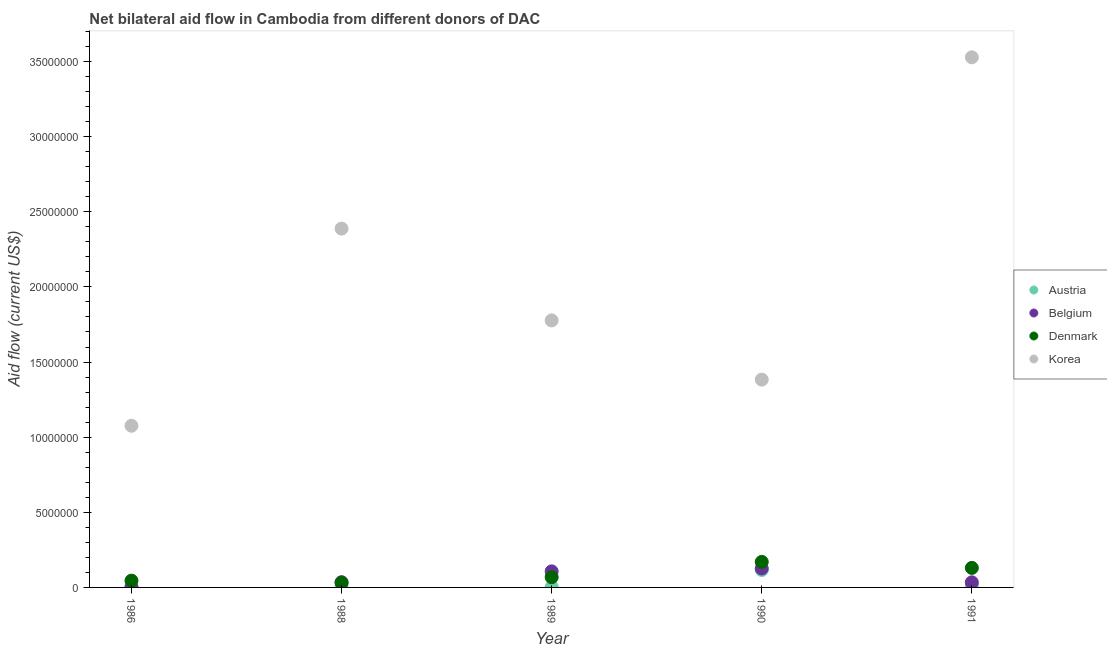How many different coloured dotlines are there?
Your answer should be compact. 4. Is the number of dotlines equal to the number of legend labels?
Ensure brevity in your answer.  Yes. What is the amount of aid given by austria in 1990?
Provide a succinct answer. 1.16e+06. Across all years, what is the maximum amount of aid given by korea?
Your answer should be compact. 3.53e+07. Across all years, what is the minimum amount of aid given by austria?
Your response must be concise. 3.00e+04. What is the total amount of aid given by denmark in the graph?
Your answer should be very brief. 4.44e+06. What is the difference between the amount of aid given by denmark in 1989 and that in 1990?
Offer a terse response. -1.02e+06. What is the difference between the amount of aid given by korea in 1988 and the amount of aid given by austria in 1986?
Provide a succinct answer. 2.38e+07. What is the average amount of aid given by denmark per year?
Provide a succinct answer. 8.88e+05. In the year 1988, what is the difference between the amount of aid given by austria and amount of aid given by belgium?
Your answer should be compact. -3.10e+05. What is the ratio of the amount of aid given by austria in 1988 to that in 1989?
Provide a succinct answer. 1.33. Is the amount of aid given by austria in 1986 less than that in 1991?
Offer a terse response. Yes. What is the difference between the highest and the lowest amount of aid given by korea?
Provide a short and direct response. 2.45e+07. Is it the case that in every year, the sum of the amount of aid given by denmark and amount of aid given by austria is greater than the sum of amount of aid given by belgium and amount of aid given by korea?
Your answer should be very brief. Yes. Is it the case that in every year, the sum of the amount of aid given by austria and amount of aid given by belgium is greater than the amount of aid given by denmark?
Ensure brevity in your answer.  No. Does the amount of aid given by austria monotonically increase over the years?
Keep it short and to the point. No. Is the amount of aid given by korea strictly less than the amount of aid given by austria over the years?
Provide a short and direct response. No. How many dotlines are there?
Give a very brief answer. 4. How many years are there in the graph?
Keep it short and to the point. 5. What is the difference between two consecutive major ticks on the Y-axis?
Your response must be concise. 5.00e+06. Does the graph contain any zero values?
Your answer should be very brief. No. Does the graph contain grids?
Offer a terse response. No. Where does the legend appear in the graph?
Give a very brief answer. Center right. How are the legend labels stacked?
Make the answer very short. Vertical. What is the title of the graph?
Provide a short and direct response. Net bilateral aid flow in Cambodia from different donors of DAC. Does "Secondary vocational" appear as one of the legend labels in the graph?
Provide a succinct answer. No. What is the label or title of the X-axis?
Provide a short and direct response. Year. What is the Aid flow (current US$) in Austria in 1986?
Your answer should be compact. 4.00e+04. What is the Aid flow (current US$) in Belgium in 1986?
Your answer should be very brief. 2.00e+04. What is the Aid flow (current US$) of Korea in 1986?
Your answer should be very brief. 1.08e+07. What is the Aid flow (current US$) in Austria in 1988?
Provide a succinct answer. 4.00e+04. What is the Aid flow (current US$) in Belgium in 1988?
Offer a terse response. 3.50e+05. What is the Aid flow (current US$) of Denmark in 1988?
Your answer should be very brief. 3.10e+05. What is the Aid flow (current US$) in Korea in 1988?
Ensure brevity in your answer.  2.39e+07. What is the Aid flow (current US$) in Austria in 1989?
Provide a short and direct response. 3.00e+04. What is the Aid flow (current US$) of Belgium in 1989?
Your response must be concise. 1.07e+06. What is the Aid flow (current US$) in Denmark in 1989?
Your answer should be compact. 6.80e+05. What is the Aid flow (current US$) of Korea in 1989?
Give a very brief answer. 1.78e+07. What is the Aid flow (current US$) of Austria in 1990?
Provide a short and direct response. 1.16e+06. What is the Aid flow (current US$) in Belgium in 1990?
Keep it short and to the point. 1.26e+06. What is the Aid flow (current US$) of Denmark in 1990?
Your answer should be compact. 1.70e+06. What is the Aid flow (current US$) in Korea in 1990?
Ensure brevity in your answer.  1.38e+07. What is the Aid flow (current US$) in Belgium in 1991?
Your answer should be compact. 3.40e+05. What is the Aid flow (current US$) of Denmark in 1991?
Your response must be concise. 1.30e+06. What is the Aid flow (current US$) in Korea in 1991?
Your response must be concise. 3.53e+07. Across all years, what is the maximum Aid flow (current US$) in Austria?
Your response must be concise. 1.16e+06. Across all years, what is the maximum Aid flow (current US$) of Belgium?
Your answer should be very brief. 1.26e+06. Across all years, what is the maximum Aid flow (current US$) in Denmark?
Give a very brief answer. 1.70e+06. Across all years, what is the maximum Aid flow (current US$) of Korea?
Your response must be concise. 3.53e+07. Across all years, what is the minimum Aid flow (current US$) in Austria?
Provide a succinct answer. 3.00e+04. Across all years, what is the minimum Aid flow (current US$) of Belgium?
Ensure brevity in your answer.  2.00e+04. Across all years, what is the minimum Aid flow (current US$) of Korea?
Make the answer very short. 1.08e+07. What is the total Aid flow (current US$) of Austria in the graph?
Offer a very short reply. 1.36e+06. What is the total Aid flow (current US$) of Belgium in the graph?
Your response must be concise. 3.04e+06. What is the total Aid flow (current US$) of Denmark in the graph?
Give a very brief answer. 4.44e+06. What is the total Aid flow (current US$) of Korea in the graph?
Offer a very short reply. 1.02e+08. What is the difference between the Aid flow (current US$) of Austria in 1986 and that in 1988?
Your response must be concise. 0. What is the difference between the Aid flow (current US$) of Belgium in 1986 and that in 1988?
Your response must be concise. -3.30e+05. What is the difference between the Aid flow (current US$) in Denmark in 1986 and that in 1988?
Offer a very short reply. 1.40e+05. What is the difference between the Aid flow (current US$) of Korea in 1986 and that in 1988?
Offer a very short reply. -1.31e+07. What is the difference between the Aid flow (current US$) of Belgium in 1986 and that in 1989?
Give a very brief answer. -1.05e+06. What is the difference between the Aid flow (current US$) of Denmark in 1986 and that in 1989?
Your answer should be compact. -2.30e+05. What is the difference between the Aid flow (current US$) of Korea in 1986 and that in 1989?
Keep it short and to the point. -7.01e+06. What is the difference between the Aid flow (current US$) of Austria in 1986 and that in 1990?
Your answer should be very brief. -1.12e+06. What is the difference between the Aid flow (current US$) in Belgium in 1986 and that in 1990?
Keep it short and to the point. -1.24e+06. What is the difference between the Aid flow (current US$) in Denmark in 1986 and that in 1990?
Your answer should be very brief. -1.25e+06. What is the difference between the Aid flow (current US$) in Korea in 1986 and that in 1990?
Your answer should be compact. -3.07e+06. What is the difference between the Aid flow (current US$) in Belgium in 1986 and that in 1991?
Provide a succinct answer. -3.20e+05. What is the difference between the Aid flow (current US$) in Denmark in 1986 and that in 1991?
Make the answer very short. -8.50e+05. What is the difference between the Aid flow (current US$) in Korea in 1986 and that in 1991?
Keep it short and to the point. -2.45e+07. What is the difference between the Aid flow (current US$) of Austria in 1988 and that in 1989?
Provide a succinct answer. 10000. What is the difference between the Aid flow (current US$) in Belgium in 1988 and that in 1989?
Your answer should be very brief. -7.20e+05. What is the difference between the Aid flow (current US$) of Denmark in 1988 and that in 1989?
Offer a terse response. -3.70e+05. What is the difference between the Aid flow (current US$) of Korea in 1988 and that in 1989?
Your answer should be compact. 6.11e+06. What is the difference between the Aid flow (current US$) of Austria in 1988 and that in 1990?
Offer a terse response. -1.12e+06. What is the difference between the Aid flow (current US$) in Belgium in 1988 and that in 1990?
Your answer should be very brief. -9.10e+05. What is the difference between the Aid flow (current US$) of Denmark in 1988 and that in 1990?
Give a very brief answer. -1.39e+06. What is the difference between the Aid flow (current US$) of Korea in 1988 and that in 1990?
Your response must be concise. 1.00e+07. What is the difference between the Aid flow (current US$) in Belgium in 1988 and that in 1991?
Provide a short and direct response. 10000. What is the difference between the Aid flow (current US$) of Denmark in 1988 and that in 1991?
Your response must be concise. -9.90e+05. What is the difference between the Aid flow (current US$) of Korea in 1988 and that in 1991?
Offer a very short reply. -1.14e+07. What is the difference between the Aid flow (current US$) of Austria in 1989 and that in 1990?
Keep it short and to the point. -1.13e+06. What is the difference between the Aid flow (current US$) of Denmark in 1989 and that in 1990?
Your answer should be very brief. -1.02e+06. What is the difference between the Aid flow (current US$) of Korea in 1989 and that in 1990?
Your answer should be very brief. 3.94e+06. What is the difference between the Aid flow (current US$) of Belgium in 1989 and that in 1991?
Keep it short and to the point. 7.30e+05. What is the difference between the Aid flow (current US$) of Denmark in 1989 and that in 1991?
Your answer should be very brief. -6.20e+05. What is the difference between the Aid flow (current US$) in Korea in 1989 and that in 1991?
Your answer should be very brief. -1.75e+07. What is the difference between the Aid flow (current US$) of Austria in 1990 and that in 1991?
Make the answer very short. 1.07e+06. What is the difference between the Aid flow (current US$) of Belgium in 1990 and that in 1991?
Your response must be concise. 9.20e+05. What is the difference between the Aid flow (current US$) of Denmark in 1990 and that in 1991?
Keep it short and to the point. 4.00e+05. What is the difference between the Aid flow (current US$) in Korea in 1990 and that in 1991?
Keep it short and to the point. -2.14e+07. What is the difference between the Aid flow (current US$) of Austria in 1986 and the Aid flow (current US$) of Belgium in 1988?
Keep it short and to the point. -3.10e+05. What is the difference between the Aid flow (current US$) of Austria in 1986 and the Aid flow (current US$) of Korea in 1988?
Your answer should be compact. -2.38e+07. What is the difference between the Aid flow (current US$) of Belgium in 1986 and the Aid flow (current US$) of Korea in 1988?
Give a very brief answer. -2.39e+07. What is the difference between the Aid flow (current US$) in Denmark in 1986 and the Aid flow (current US$) in Korea in 1988?
Ensure brevity in your answer.  -2.34e+07. What is the difference between the Aid flow (current US$) of Austria in 1986 and the Aid flow (current US$) of Belgium in 1989?
Give a very brief answer. -1.03e+06. What is the difference between the Aid flow (current US$) of Austria in 1986 and the Aid flow (current US$) of Denmark in 1989?
Give a very brief answer. -6.40e+05. What is the difference between the Aid flow (current US$) of Austria in 1986 and the Aid flow (current US$) of Korea in 1989?
Your answer should be very brief. -1.77e+07. What is the difference between the Aid flow (current US$) of Belgium in 1986 and the Aid flow (current US$) of Denmark in 1989?
Keep it short and to the point. -6.60e+05. What is the difference between the Aid flow (current US$) in Belgium in 1986 and the Aid flow (current US$) in Korea in 1989?
Give a very brief answer. -1.78e+07. What is the difference between the Aid flow (current US$) in Denmark in 1986 and the Aid flow (current US$) in Korea in 1989?
Offer a very short reply. -1.73e+07. What is the difference between the Aid flow (current US$) of Austria in 1986 and the Aid flow (current US$) of Belgium in 1990?
Offer a terse response. -1.22e+06. What is the difference between the Aid flow (current US$) in Austria in 1986 and the Aid flow (current US$) in Denmark in 1990?
Ensure brevity in your answer.  -1.66e+06. What is the difference between the Aid flow (current US$) of Austria in 1986 and the Aid flow (current US$) of Korea in 1990?
Give a very brief answer. -1.38e+07. What is the difference between the Aid flow (current US$) of Belgium in 1986 and the Aid flow (current US$) of Denmark in 1990?
Make the answer very short. -1.68e+06. What is the difference between the Aid flow (current US$) of Belgium in 1986 and the Aid flow (current US$) of Korea in 1990?
Offer a terse response. -1.38e+07. What is the difference between the Aid flow (current US$) in Denmark in 1986 and the Aid flow (current US$) in Korea in 1990?
Your response must be concise. -1.34e+07. What is the difference between the Aid flow (current US$) in Austria in 1986 and the Aid flow (current US$) in Denmark in 1991?
Offer a terse response. -1.26e+06. What is the difference between the Aid flow (current US$) of Austria in 1986 and the Aid flow (current US$) of Korea in 1991?
Give a very brief answer. -3.52e+07. What is the difference between the Aid flow (current US$) of Belgium in 1986 and the Aid flow (current US$) of Denmark in 1991?
Your answer should be very brief. -1.28e+06. What is the difference between the Aid flow (current US$) of Belgium in 1986 and the Aid flow (current US$) of Korea in 1991?
Ensure brevity in your answer.  -3.53e+07. What is the difference between the Aid flow (current US$) of Denmark in 1986 and the Aid flow (current US$) of Korea in 1991?
Provide a succinct answer. -3.48e+07. What is the difference between the Aid flow (current US$) of Austria in 1988 and the Aid flow (current US$) of Belgium in 1989?
Ensure brevity in your answer.  -1.03e+06. What is the difference between the Aid flow (current US$) of Austria in 1988 and the Aid flow (current US$) of Denmark in 1989?
Offer a terse response. -6.40e+05. What is the difference between the Aid flow (current US$) of Austria in 1988 and the Aid flow (current US$) of Korea in 1989?
Keep it short and to the point. -1.77e+07. What is the difference between the Aid flow (current US$) in Belgium in 1988 and the Aid flow (current US$) in Denmark in 1989?
Your answer should be compact. -3.30e+05. What is the difference between the Aid flow (current US$) of Belgium in 1988 and the Aid flow (current US$) of Korea in 1989?
Give a very brief answer. -1.74e+07. What is the difference between the Aid flow (current US$) of Denmark in 1988 and the Aid flow (current US$) of Korea in 1989?
Give a very brief answer. -1.75e+07. What is the difference between the Aid flow (current US$) of Austria in 1988 and the Aid flow (current US$) of Belgium in 1990?
Offer a very short reply. -1.22e+06. What is the difference between the Aid flow (current US$) of Austria in 1988 and the Aid flow (current US$) of Denmark in 1990?
Provide a succinct answer. -1.66e+06. What is the difference between the Aid flow (current US$) in Austria in 1988 and the Aid flow (current US$) in Korea in 1990?
Give a very brief answer. -1.38e+07. What is the difference between the Aid flow (current US$) in Belgium in 1988 and the Aid flow (current US$) in Denmark in 1990?
Ensure brevity in your answer.  -1.35e+06. What is the difference between the Aid flow (current US$) in Belgium in 1988 and the Aid flow (current US$) in Korea in 1990?
Make the answer very short. -1.35e+07. What is the difference between the Aid flow (current US$) in Denmark in 1988 and the Aid flow (current US$) in Korea in 1990?
Provide a succinct answer. -1.35e+07. What is the difference between the Aid flow (current US$) in Austria in 1988 and the Aid flow (current US$) in Belgium in 1991?
Offer a terse response. -3.00e+05. What is the difference between the Aid flow (current US$) of Austria in 1988 and the Aid flow (current US$) of Denmark in 1991?
Offer a terse response. -1.26e+06. What is the difference between the Aid flow (current US$) of Austria in 1988 and the Aid flow (current US$) of Korea in 1991?
Offer a very short reply. -3.52e+07. What is the difference between the Aid flow (current US$) of Belgium in 1988 and the Aid flow (current US$) of Denmark in 1991?
Provide a succinct answer. -9.50e+05. What is the difference between the Aid flow (current US$) of Belgium in 1988 and the Aid flow (current US$) of Korea in 1991?
Give a very brief answer. -3.49e+07. What is the difference between the Aid flow (current US$) in Denmark in 1988 and the Aid flow (current US$) in Korea in 1991?
Provide a succinct answer. -3.50e+07. What is the difference between the Aid flow (current US$) in Austria in 1989 and the Aid flow (current US$) in Belgium in 1990?
Your answer should be very brief. -1.23e+06. What is the difference between the Aid flow (current US$) in Austria in 1989 and the Aid flow (current US$) in Denmark in 1990?
Give a very brief answer. -1.67e+06. What is the difference between the Aid flow (current US$) of Austria in 1989 and the Aid flow (current US$) of Korea in 1990?
Give a very brief answer. -1.38e+07. What is the difference between the Aid flow (current US$) of Belgium in 1989 and the Aid flow (current US$) of Denmark in 1990?
Your answer should be very brief. -6.30e+05. What is the difference between the Aid flow (current US$) of Belgium in 1989 and the Aid flow (current US$) of Korea in 1990?
Keep it short and to the point. -1.28e+07. What is the difference between the Aid flow (current US$) of Denmark in 1989 and the Aid flow (current US$) of Korea in 1990?
Offer a terse response. -1.32e+07. What is the difference between the Aid flow (current US$) of Austria in 1989 and the Aid flow (current US$) of Belgium in 1991?
Give a very brief answer. -3.10e+05. What is the difference between the Aid flow (current US$) in Austria in 1989 and the Aid flow (current US$) in Denmark in 1991?
Offer a terse response. -1.27e+06. What is the difference between the Aid flow (current US$) in Austria in 1989 and the Aid flow (current US$) in Korea in 1991?
Offer a very short reply. -3.52e+07. What is the difference between the Aid flow (current US$) in Belgium in 1989 and the Aid flow (current US$) in Korea in 1991?
Keep it short and to the point. -3.42e+07. What is the difference between the Aid flow (current US$) of Denmark in 1989 and the Aid flow (current US$) of Korea in 1991?
Your response must be concise. -3.46e+07. What is the difference between the Aid flow (current US$) in Austria in 1990 and the Aid flow (current US$) in Belgium in 1991?
Give a very brief answer. 8.20e+05. What is the difference between the Aid flow (current US$) of Austria in 1990 and the Aid flow (current US$) of Korea in 1991?
Your response must be concise. -3.41e+07. What is the difference between the Aid flow (current US$) in Belgium in 1990 and the Aid flow (current US$) in Korea in 1991?
Make the answer very short. -3.40e+07. What is the difference between the Aid flow (current US$) in Denmark in 1990 and the Aid flow (current US$) in Korea in 1991?
Your response must be concise. -3.36e+07. What is the average Aid flow (current US$) of Austria per year?
Provide a short and direct response. 2.72e+05. What is the average Aid flow (current US$) in Belgium per year?
Your response must be concise. 6.08e+05. What is the average Aid flow (current US$) in Denmark per year?
Your answer should be compact. 8.88e+05. What is the average Aid flow (current US$) in Korea per year?
Your response must be concise. 2.03e+07. In the year 1986, what is the difference between the Aid flow (current US$) of Austria and Aid flow (current US$) of Belgium?
Offer a very short reply. 2.00e+04. In the year 1986, what is the difference between the Aid flow (current US$) of Austria and Aid flow (current US$) of Denmark?
Your response must be concise. -4.10e+05. In the year 1986, what is the difference between the Aid flow (current US$) of Austria and Aid flow (current US$) of Korea?
Give a very brief answer. -1.07e+07. In the year 1986, what is the difference between the Aid flow (current US$) of Belgium and Aid flow (current US$) of Denmark?
Your answer should be very brief. -4.30e+05. In the year 1986, what is the difference between the Aid flow (current US$) in Belgium and Aid flow (current US$) in Korea?
Provide a short and direct response. -1.07e+07. In the year 1986, what is the difference between the Aid flow (current US$) in Denmark and Aid flow (current US$) in Korea?
Offer a very short reply. -1.03e+07. In the year 1988, what is the difference between the Aid flow (current US$) in Austria and Aid flow (current US$) in Belgium?
Provide a short and direct response. -3.10e+05. In the year 1988, what is the difference between the Aid flow (current US$) in Austria and Aid flow (current US$) in Korea?
Provide a short and direct response. -2.38e+07. In the year 1988, what is the difference between the Aid flow (current US$) in Belgium and Aid flow (current US$) in Denmark?
Provide a succinct answer. 4.00e+04. In the year 1988, what is the difference between the Aid flow (current US$) of Belgium and Aid flow (current US$) of Korea?
Your answer should be very brief. -2.35e+07. In the year 1988, what is the difference between the Aid flow (current US$) of Denmark and Aid flow (current US$) of Korea?
Your answer should be very brief. -2.36e+07. In the year 1989, what is the difference between the Aid flow (current US$) of Austria and Aid flow (current US$) of Belgium?
Keep it short and to the point. -1.04e+06. In the year 1989, what is the difference between the Aid flow (current US$) in Austria and Aid flow (current US$) in Denmark?
Ensure brevity in your answer.  -6.50e+05. In the year 1989, what is the difference between the Aid flow (current US$) of Austria and Aid flow (current US$) of Korea?
Offer a terse response. -1.77e+07. In the year 1989, what is the difference between the Aid flow (current US$) of Belgium and Aid flow (current US$) of Korea?
Your answer should be compact. -1.67e+07. In the year 1989, what is the difference between the Aid flow (current US$) of Denmark and Aid flow (current US$) of Korea?
Offer a terse response. -1.71e+07. In the year 1990, what is the difference between the Aid flow (current US$) in Austria and Aid flow (current US$) in Belgium?
Offer a terse response. -1.00e+05. In the year 1990, what is the difference between the Aid flow (current US$) in Austria and Aid flow (current US$) in Denmark?
Ensure brevity in your answer.  -5.40e+05. In the year 1990, what is the difference between the Aid flow (current US$) in Austria and Aid flow (current US$) in Korea?
Provide a succinct answer. -1.27e+07. In the year 1990, what is the difference between the Aid flow (current US$) in Belgium and Aid flow (current US$) in Denmark?
Make the answer very short. -4.40e+05. In the year 1990, what is the difference between the Aid flow (current US$) in Belgium and Aid flow (current US$) in Korea?
Your answer should be compact. -1.26e+07. In the year 1990, what is the difference between the Aid flow (current US$) in Denmark and Aid flow (current US$) in Korea?
Provide a short and direct response. -1.21e+07. In the year 1991, what is the difference between the Aid flow (current US$) of Austria and Aid flow (current US$) of Belgium?
Your answer should be very brief. -2.50e+05. In the year 1991, what is the difference between the Aid flow (current US$) in Austria and Aid flow (current US$) in Denmark?
Make the answer very short. -1.21e+06. In the year 1991, what is the difference between the Aid flow (current US$) in Austria and Aid flow (current US$) in Korea?
Provide a succinct answer. -3.52e+07. In the year 1991, what is the difference between the Aid flow (current US$) in Belgium and Aid flow (current US$) in Denmark?
Keep it short and to the point. -9.60e+05. In the year 1991, what is the difference between the Aid flow (current US$) in Belgium and Aid flow (current US$) in Korea?
Offer a terse response. -3.49e+07. In the year 1991, what is the difference between the Aid flow (current US$) of Denmark and Aid flow (current US$) of Korea?
Offer a very short reply. -3.40e+07. What is the ratio of the Aid flow (current US$) of Belgium in 1986 to that in 1988?
Your answer should be compact. 0.06. What is the ratio of the Aid flow (current US$) of Denmark in 1986 to that in 1988?
Give a very brief answer. 1.45. What is the ratio of the Aid flow (current US$) in Korea in 1986 to that in 1988?
Give a very brief answer. 0.45. What is the ratio of the Aid flow (current US$) of Austria in 1986 to that in 1989?
Your response must be concise. 1.33. What is the ratio of the Aid flow (current US$) in Belgium in 1986 to that in 1989?
Your answer should be compact. 0.02. What is the ratio of the Aid flow (current US$) of Denmark in 1986 to that in 1989?
Make the answer very short. 0.66. What is the ratio of the Aid flow (current US$) in Korea in 1986 to that in 1989?
Your answer should be very brief. 0.61. What is the ratio of the Aid flow (current US$) in Austria in 1986 to that in 1990?
Your answer should be very brief. 0.03. What is the ratio of the Aid flow (current US$) in Belgium in 1986 to that in 1990?
Make the answer very short. 0.02. What is the ratio of the Aid flow (current US$) of Denmark in 1986 to that in 1990?
Make the answer very short. 0.26. What is the ratio of the Aid flow (current US$) in Korea in 1986 to that in 1990?
Make the answer very short. 0.78. What is the ratio of the Aid flow (current US$) in Austria in 1986 to that in 1991?
Offer a terse response. 0.44. What is the ratio of the Aid flow (current US$) in Belgium in 1986 to that in 1991?
Your answer should be very brief. 0.06. What is the ratio of the Aid flow (current US$) of Denmark in 1986 to that in 1991?
Provide a succinct answer. 0.35. What is the ratio of the Aid flow (current US$) in Korea in 1986 to that in 1991?
Provide a succinct answer. 0.3. What is the ratio of the Aid flow (current US$) in Austria in 1988 to that in 1989?
Make the answer very short. 1.33. What is the ratio of the Aid flow (current US$) in Belgium in 1988 to that in 1989?
Keep it short and to the point. 0.33. What is the ratio of the Aid flow (current US$) in Denmark in 1988 to that in 1989?
Make the answer very short. 0.46. What is the ratio of the Aid flow (current US$) in Korea in 1988 to that in 1989?
Your answer should be very brief. 1.34. What is the ratio of the Aid flow (current US$) of Austria in 1988 to that in 1990?
Your answer should be very brief. 0.03. What is the ratio of the Aid flow (current US$) of Belgium in 1988 to that in 1990?
Give a very brief answer. 0.28. What is the ratio of the Aid flow (current US$) in Denmark in 1988 to that in 1990?
Your response must be concise. 0.18. What is the ratio of the Aid flow (current US$) in Korea in 1988 to that in 1990?
Offer a terse response. 1.73. What is the ratio of the Aid flow (current US$) in Austria in 1988 to that in 1991?
Offer a terse response. 0.44. What is the ratio of the Aid flow (current US$) of Belgium in 1988 to that in 1991?
Offer a very short reply. 1.03. What is the ratio of the Aid flow (current US$) of Denmark in 1988 to that in 1991?
Your answer should be very brief. 0.24. What is the ratio of the Aid flow (current US$) in Korea in 1988 to that in 1991?
Your answer should be compact. 0.68. What is the ratio of the Aid flow (current US$) in Austria in 1989 to that in 1990?
Your answer should be very brief. 0.03. What is the ratio of the Aid flow (current US$) of Belgium in 1989 to that in 1990?
Your answer should be compact. 0.85. What is the ratio of the Aid flow (current US$) in Denmark in 1989 to that in 1990?
Offer a very short reply. 0.4. What is the ratio of the Aid flow (current US$) of Korea in 1989 to that in 1990?
Your answer should be very brief. 1.28. What is the ratio of the Aid flow (current US$) of Austria in 1989 to that in 1991?
Offer a very short reply. 0.33. What is the ratio of the Aid flow (current US$) of Belgium in 1989 to that in 1991?
Your answer should be compact. 3.15. What is the ratio of the Aid flow (current US$) in Denmark in 1989 to that in 1991?
Your answer should be very brief. 0.52. What is the ratio of the Aid flow (current US$) in Korea in 1989 to that in 1991?
Your answer should be compact. 0.5. What is the ratio of the Aid flow (current US$) of Austria in 1990 to that in 1991?
Keep it short and to the point. 12.89. What is the ratio of the Aid flow (current US$) in Belgium in 1990 to that in 1991?
Your answer should be very brief. 3.71. What is the ratio of the Aid flow (current US$) of Denmark in 1990 to that in 1991?
Your answer should be compact. 1.31. What is the ratio of the Aid flow (current US$) of Korea in 1990 to that in 1991?
Make the answer very short. 0.39. What is the difference between the highest and the second highest Aid flow (current US$) of Austria?
Ensure brevity in your answer.  1.07e+06. What is the difference between the highest and the second highest Aid flow (current US$) of Denmark?
Offer a very short reply. 4.00e+05. What is the difference between the highest and the second highest Aid flow (current US$) in Korea?
Your answer should be compact. 1.14e+07. What is the difference between the highest and the lowest Aid flow (current US$) of Austria?
Your response must be concise. 1.13e+06. What is the difference between the highest and the lowest Aid flow (current US$) of Belgium?
Provide a succinct answer. 1.24e+06. What is the difference between the highest and the lowest Aid flow (current US$) of Denmark?
Keep it short and to the point. 1.39e+06. What is the difference between the highest and the lowest Aid flow (current US$) in Korea?
Give a very brief answer. 2.45e+07. 